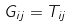Convert formula to latex. <formula><loc_0><loc_0><loc_500><loc_500>G _ { i j } = T _ { i j }</formula> 